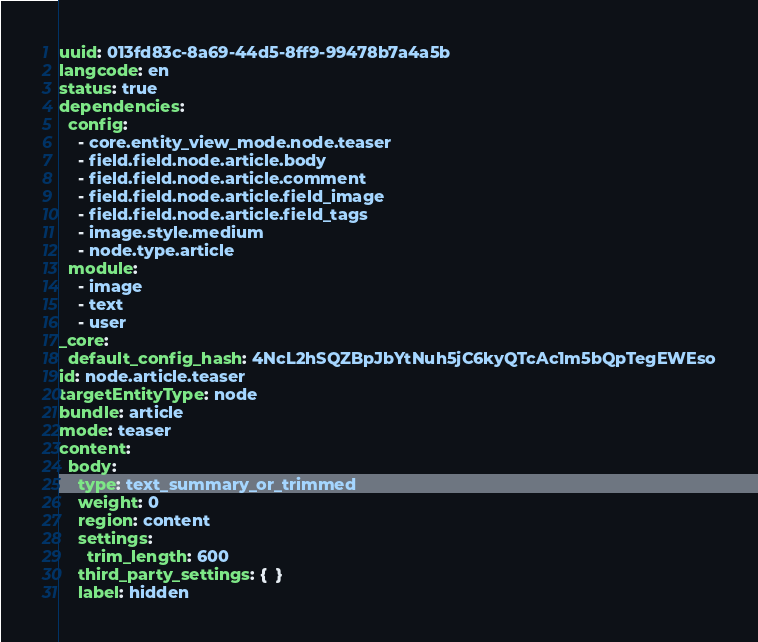<code> <loc_0><loc_0><loc_500><loc_500><_YAML_>uuid: 013fd83c-8a69-44d5-8ff9-99478b7a4a5b
langcode: en
status: true
dependencies:
  config:
    - core.entity_view_mode.node.teaser
    - field.field.node.article.body
    - field.field.node.article.comment
    - field.field.node.article.field_image
    - field.field.node.article.field_tags
    - image.style.medium
    - node.type.article
  module:
    - image
    - text
    - user
_core:
  default_config_hash: 4NcL2hSQZBpJbYtNuh5jC6kyQTcAc1m5bQpTegEWEso
id: node.article.teaser
targetEntityType: node
bundle: article
mode: teaser
content:
  body:
    type: text_summary_or_trimmed
    weight: 0
    region: content
    settings:
      trim_length: 600
    third_party_settings: {  }
    label: hidden</code> 